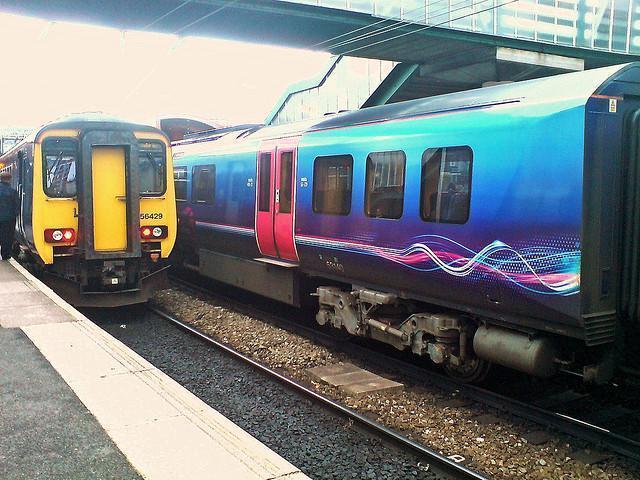What structure is present above the parked trains on the rail tracks?
Choose the right answer and clarify with the format: 'Answer: answer
Rationale: rationale.'
Options: Passenger walkway, parking garage, electric line, waiting area. Answer: passenger walkway.
Rationale: The structure is clearly visible and based on its size and design and placement over the train tracks, answer a is consistent. 